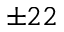Convert formula to latex. <formula><loc_0><loc_0><loc_500><loc_500>\pm 2 2</formula> 